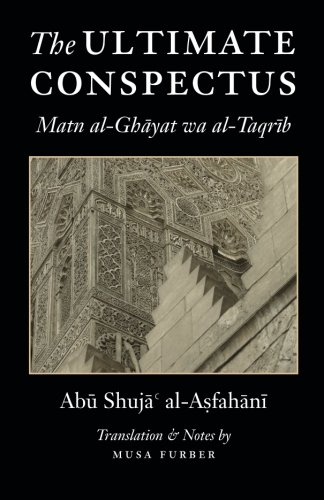What type of book is this? This is a book under the genre of Religion & Spirituality, specifically focusing on Islamic theology and jurisprudence. 